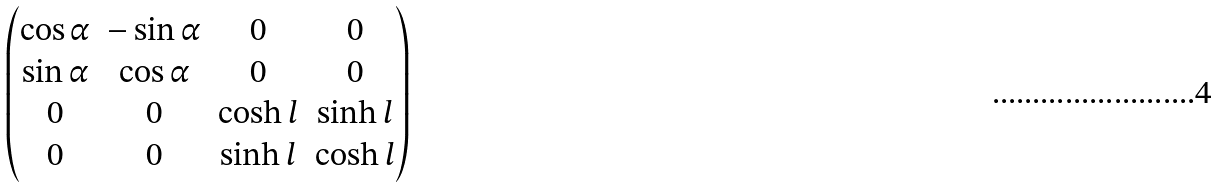Convert formula to latex. <formula><loc_0><loc_0><loc_500><loc_500>\begin{pmatrix} \cos \alpha & - \sin \alpha & 0 & 0 \\ \sin \alpha & \cos \alpha & 0 & 0 \\ 0 & 0 & \cosh l & \sinh l \\ 0 & 0 & \sinh l & \cosh l \\ \end{pmatrix}</formula> 